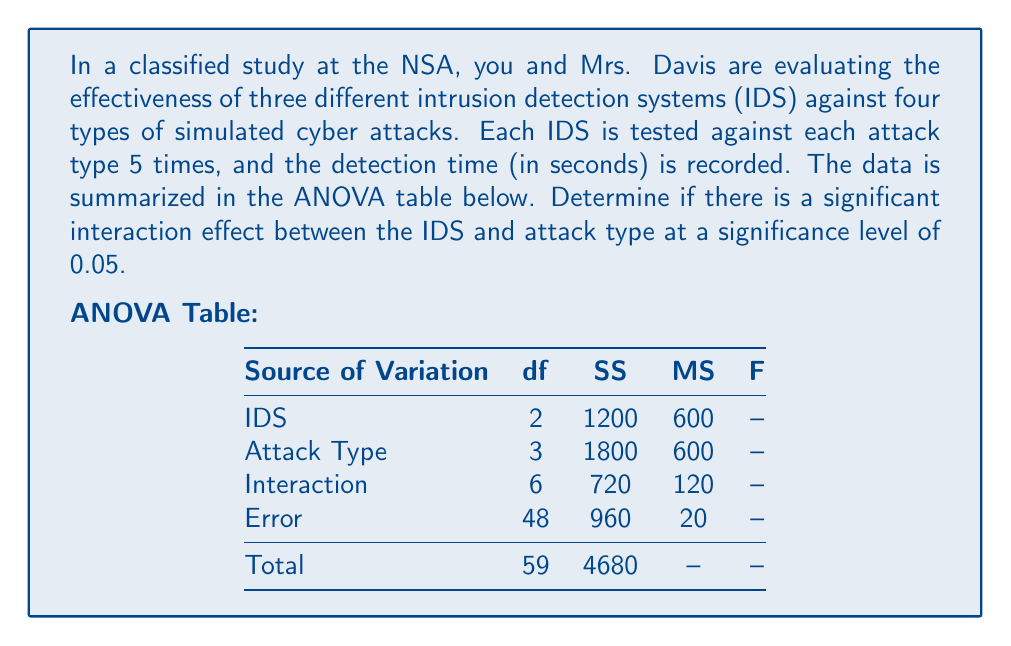Give your solution to this math problem. To determine if there is a significant interaction effect between the IDS and attack type, we need to conduct an F-test for the interaction term. Let's follow these steps:

1. Identify the null and alternative hypotheses:
   $H_0$: There is no interaction effect between IDS and attack type
   $H_a$: There is an interaction effect between IDS and attack type

2. Calculate the F-statistic for the interaction:
   $F = \frac{MS_{interaction}}{MS_{error}} = \frac{120}{20} = 6$

3. Determine the critical F-value:
   - Degrees of freedom for numerator (interaction) = 6
   - Degrees of freedom for denominator (error) = 48
   - Significance level α = 0.05
   
   Using an F-distribution table or calculator, we find:
   $F_{critical} = F_{0.05, 6, 48} ≈ 2.29$

4. Compare the calculated F-statistic to the critical F-value:
   Since $F_{calculated} = 6 > F_{critical} = 2.29$, we reject the null hypothesis.

5. Calculate the p-value:
   Using an F-distribution calculator, we find that the p-value for F(6, 48) = 6 is approximately 0.00008, which is less than 0.05.

Given that the calculated F-statistic is greater than the critical F-value and the p-value is less than the significance level of 0.05, we conclude that there is strong evidence of a significant interaction effect between the IDS and attack type.

This interaction suggests that the effectiveness of each IDS varies depending on the type of cyber attack it's facing, which is crucial information for the NSA's cybersecurity strategies.
Answer: Yes, there is a significant interaction effect between the IDS and attack type (F(6, 48) = 6, p < 0.05). 